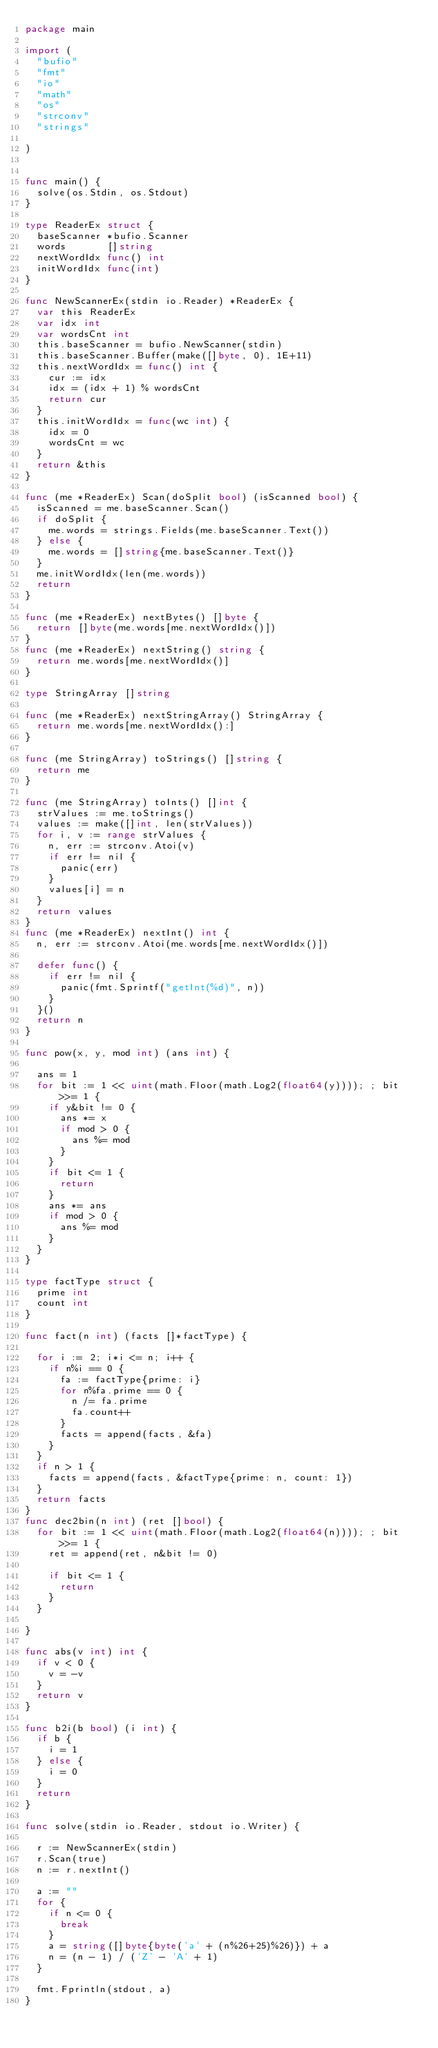<code> <loc_0><loc_0><loc_500><loc_500><_Go_>package main

import (
	"bufio"
	"fmt"
	"io"
	"math"
	"os"
	"strconv"
	"strings"

)


func main() {
	solve(os.Stdin, os.Stdout)
}

type ReaderEx struct {
	baseScanner *bufio.Scanner
	words       []string
	nextWordIdx func() int
	initWordIdx func(int)
}

func NewScannerEx(stdin io.Reader) *ReaderEx {
	var this ReaderEx
	var idx int
	var wordsCnt int
	this.baseScanner = bufio.NewScanner(stdin)
	this.baseScanner.Buffer(make([]byte, 0), 1E+11)
	this.nextWordIdx = func() int {
		cur := idx
		idx = (idx + 1) % wordsCnt
		return cur
	}
	this.initWordIdx = func(wc int) {
		idx = 0
		wordsCnt = wc
	}
	return &this
}

func (me *ReaderEx) Scan(doSplit bool) (isScanned bool) {
	isScanned = me.baseScanner.Scan()
	if doSplit {
		me.words = strings.Fields(me.baseScanner.Text())
	} else {
		me.words = []string{me.baseScanner.Text()}
	}
	me.initWordIdx(len(me.words))
	return
}

func (me *ReaderEx) nextBytes() []byte {
	return []byte(me.words[me.nextWordIdx()])
}
func (me *ReaderEx) nextString() string {
	return me.words[me.nextWordIdx()]
}

type StringArray []string

func (me *ReaderEx) nextStringArray() StringArray {
	return me.words[me.nextWordIdx():]
}

func (me StringArray) toStrings() []string {
	return me
}

func (me StringArray) toInts() []int {
	strValues := me.toStrings()
	values := make([]int, len(strValues))
	for i, v := range strValues {
		n, err := strconv.Atoi(v)
		if err != nil {
			panic(err)
		}
		values[i] = n
	}
	return values
}
func (me *ReaderEx) nextInt() int {
	n, err := strconv.Atoi(me.words[me.nextWordIdx()])

	defer func() {
		if err != nil {
			panic(fmt.Sprintf("getInt(%d)", n))
		}
	}()
	return n
}

func pow(x, y, mod int) (ans int) {

	ans = 1
	for bit := 1 << uint(math.Floor(math.Log2(float64(y)))); ; bit >>= 1 {
		if y&bit != 0 {
			ans *= x
			if mod > 0 {
				ans %= mod
			}
		}
		if bit <= 1 {
			return
		}
		ans *= ans
		if mod > 0 {
			ans %= mod
		}
	}
}

type factType struct {
	prime int
	count int
}

func fact(n int) (facts []*factType) {

	for i := 2; i*i <= n; i++ {
		if n%i == 0 {
			fa := factType{prime: i}
			for n%fa.prime == 0 {
				n /= fa.prime
				fa.count++
			}
			facts = append(facts, &fa)
		}
	}
	if n > 1 {
		facts = append(facts, &factType{prime: n, count: 1})
	}
	return facts
}
func dec2bin(n int) (ret []bool) {
	for bit := 1 << uint(math.Floor(math.Log2(float64(n)))); ; bit >>= 1 {
		ret = append(ret, n&bit != 0)

		if bit <= 1 {
			return
		}
	}

}

func abs(v int) int {
	if v < 0 {
		v = -v
	}
	return v
}

func b2i(b bool) (i int) {
	if b {
		i = 1
	} else {
		i = 0
	}
	return
}

func solve(stdin io.Reader, stdout io.Writer) {

	r := NewScannerEx(stdin)
	r.Scan(true)
	n := r.nextInt()

	a := ""
	for {
		if n <= 0 {
			break
		}
		a = string([]byte{byte('a' + (n%26+25)%26)}) + a
		n = (n - 1) / ('Z' - 'A' + 1)
	}

	fmt.Fprintln(stdout, a)
}
</code> 